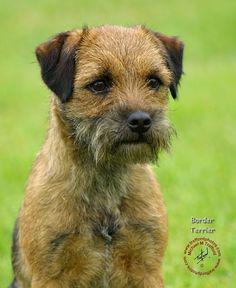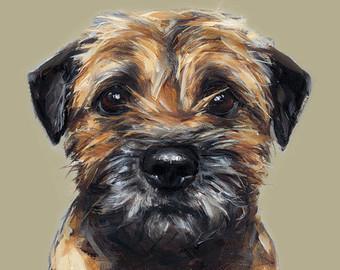The first image is the image on the left, the second image is the image on the right. Considering the images on both sides, is "A dog is wearing a collar." valid? Answer yes or no. No. The first image is the image on the left, the second image is the image on the right. Assess this claim about the two images: "Left image shows one upright dog looking slightly downward and rightward.". Correct or not? Answer yes or no. Yes. 